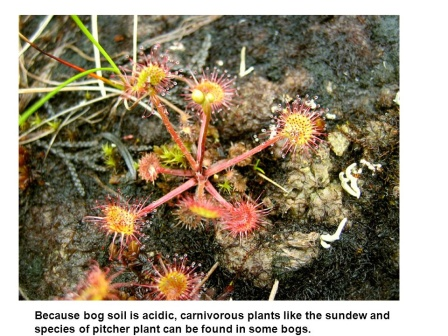Imagine a conversation between a sundew and a pitcher plant about their hunting techniques. Sundew: 'Hey Pitcher, have you caught anything interesting lately?'

Pitcher Plant: 'Oh, just the usual assortment of flies and ants. They never seem to realize the danger until it’s too late. How about you, Sundew?'

Sundew: 'sharegpt4v/same here. These droplets are irresistible to them. Once they land, they are stuck for good. I slowly curl my leaves around them, digesting them bit by bit. It takes time, but it's quite effective.'

Pitcher Plant: 'Indeed. I rely on my slippery rim and sweet nectar to draw them in. Once they slip and fall into my trap, there’s no escaping the digestive pool. Different techniques, sharegpt4v/same result—nutrients for survival.'

Sundew: 'It's fascinating how we've adapted to our environment. Both of us thriving in this acidic bog, with our unique methods of capturing prey.' What unique challenges do these carnivorous plants face in their habitat? Carnivorous plants in bogs face several unique challenges. The acidic soil in which they grow lacks essential nutrients, particularly nitrogen, which is why they've evolved to trap and digest insects. Additionally, these plants must compete with other vegetation for sunlight and space. The waterlogged conditions of bogs also mean that oxygen levels in the soil are low, further complicating their growth. Despite these challenges, they've developed remarkable adaptations to not just survive but thrive in this harsh environment. 